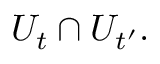<formula> <loc_0><loc_0><loc_500><loc_500>U _ { t } \cap U _ { t ^ { \prime } } .</formula> 